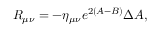Convert formula to latex. <formula><loc_0><loc_0><loc_500><loc_500>R _ { \mu \nu } = - \eta _ { \mu \nu } e ^ { 2 ( A - B ) } \Delta A ,</formula> 